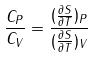Convert formula to latex. <formula><loc_0><loc_0><loc_500><loc_500>\frac { C _ { P } } { C _ { V } } = \frac { ( \frac { \partial S } { \partial T } ) _ { P } } { ( \frac { \partial S } { \partial T } ) _ { V } }</formula> 